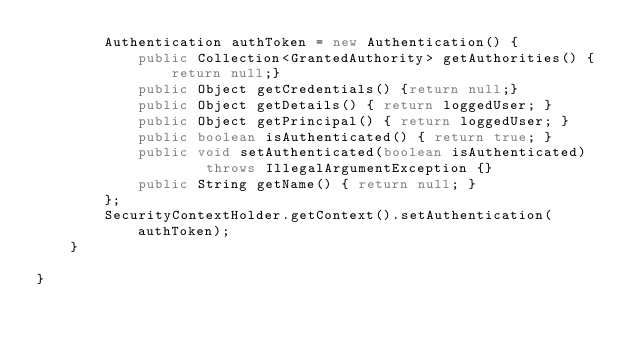Convert code to text. <code><loc_0><loc_0><loc_500><loc_500><_Java_>		Authentication authToken = new Authentication() {
			public Collection<GrantedAuthority> getAuthorities() {return null;}
			public Object getCredentials() {return null;}
			public Object getDetails() { return loggedUser; }
			public Object getPrincipal() { return loggedUser; }
			public boolean isAuthenticated() { return true; }
			public void setAuthenticated(boolean isAuthenticated)
					throws IllegalArgumentException {}
			public String getName() { return null; }
		};
		SecurityContextHolder.getContext().setAuthentication(authToken);
	}
	
}
</code> 